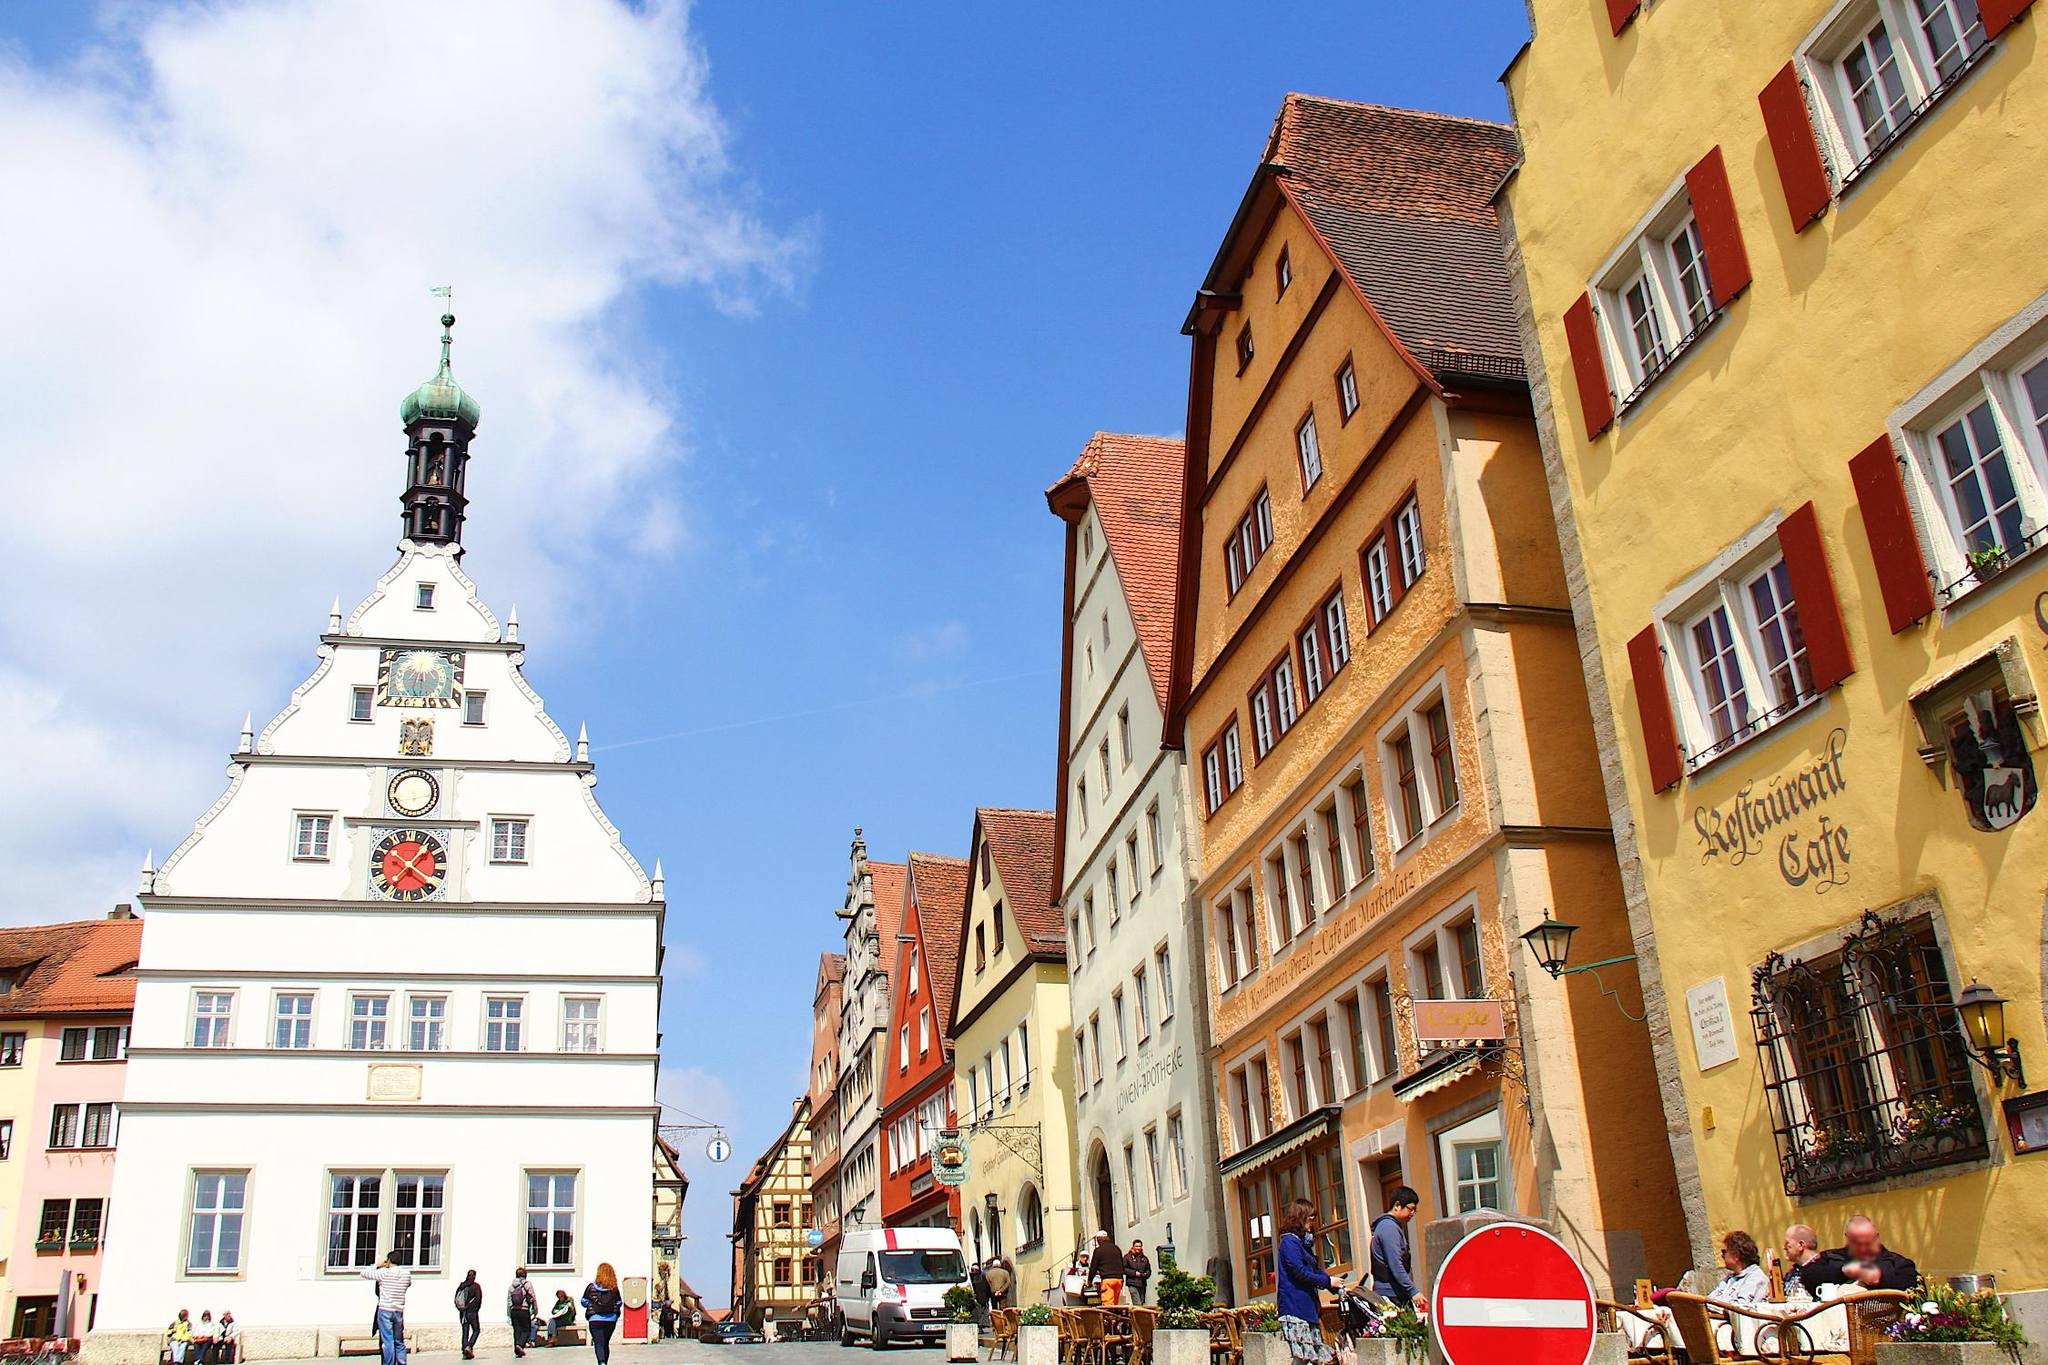What's happening in the scene? The image showcases a lively day on a street in Rothenburg ob der Tauber, Germany, featuring a mix of tourists and locals. The colorful facades of the buildings, ranging from shades of yellow to red with white trim, reflect the town's rich medieval heritage. The architecture is distinctly European, with steeply pitched roofs and ornate gables that tell tales of the town's past. On the right, a cafe, 'Kaffeehaus Café,' invites visitors to enjoy the bustling street view over a cup of coffee, while the street is lined with people engaged in shopping and photography. The clear blue sky above adds a fresh, airy feel to the scene, perfect for a leisurely day out. 